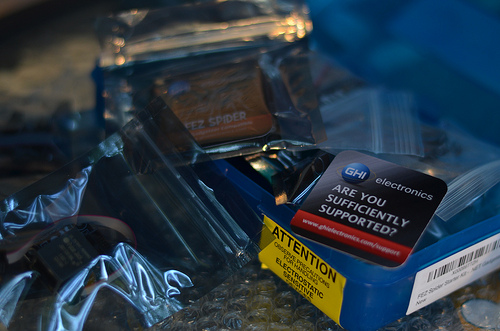<image>
Is the card on the yellow tag? No. The card is not positioned on the yellow tag. They may be near each other, but the card is not supported by or resting on top of the yellow tag. 